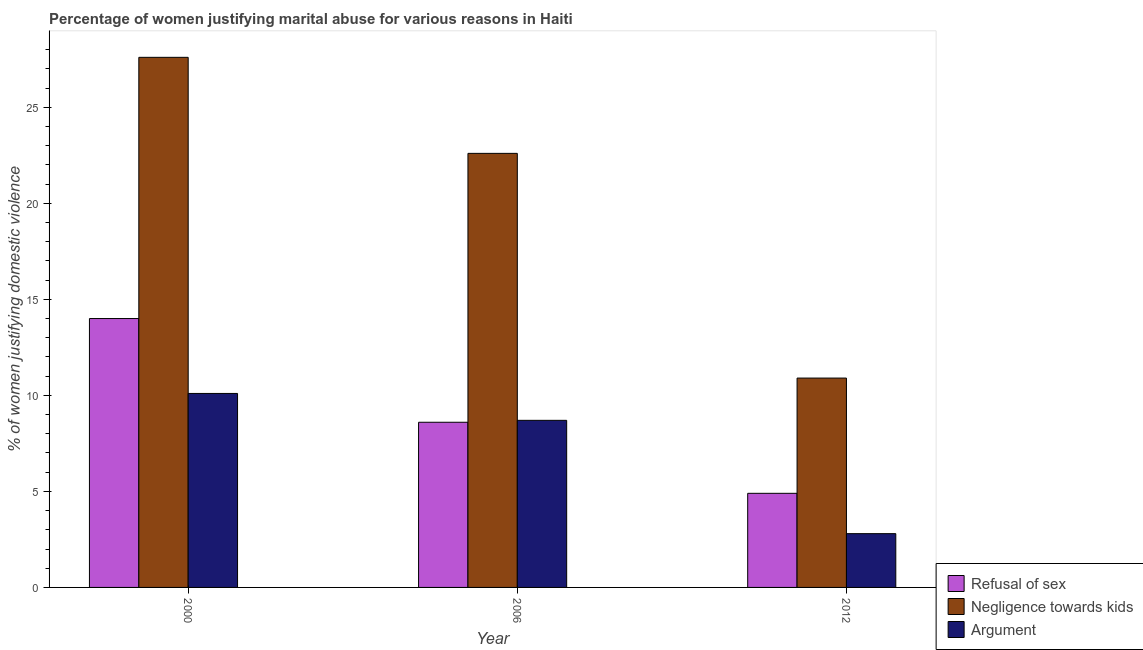How many different coloured bars are there?
Offer a very short reply. 3. How many groups of bars are there?
Offer a very short reply. 3. Are the number of bars per tick equal to the number of legend labels?
Provide a succinct answer. Yes. How many bars are there on the 1st tick from the left?
Provide a succinct answer. 3. What is the label of the 3rd group of bars from the left?
Provide a succinct answer. 2012. What is the percentage of women justifying domestic violence due to refusal of sex in 2006?
Keep it short and to the point. 8.6. Across all years, what is the minimum percentage of women justifying domestic violence due to arguments?
Provide a short and direct response. 2.8. In which year was the percentage of women justifying domestic violence due to refusal of sex maximum?
Offer a very short reply. 2000. What is the total percentage of women justifying domestic violence due to refusal of sex in the graph?
Offer a very short reply. 27.5. What is the average percentage of women justifying domestic violence due to refusal of sex per year?
Offer a terse response. 9.17. In how many years, is the percentage of women justifying domestic violence due to arguments greater than 21 %?
Your response must be concise. 0. What is the ratio of the percentage of women justifying domestic violence due to negligence towards kids in 2006 to that in 2012?
Keep it short and to the point. 2.07. Is the percentage of women justifying domestic violence due to arguments in 2000 less than that in 2012?
Ensure brevity in your answer.  No. What is the difference between the highest and the second highest percentage of women justifying domestic violence due to arguments?
Provide a succinct answer. 1.4. Is the sum of the percentage of women justifying domestic violence due to negligence towards kids in 2000 and 2006 greater than the maximum percentage of women justifying domestic violence due to refusal of sex across all years?
Your answer should be very brief. Yes. What does the 3rd bar from the left in 2012 represents?
Your response must be concise. Argument. What does the 1st bar from the right in 2000 represents?
Provide a short and direct response. Argument. Is it the case that in every year, the sum of the percentage of women justifying domestic violence due to refusal of sex and percentage of women justifying domestic violence due to negligence towards kids is greater than the percentage of women justifying domestic violence due to arguments?
Provide a succinct answer. Yes. How many bars are there?
Your answer should be very brief. 9. Are all the bars in the graph horizontal?
Your answer should be compact. No. Are the values on the major ticks of Y-axis written in scientific E-notation?
Keep it short and to the point. No. Does the graph contain any zero values?
Keep it short and to the point. No. Does the graph contain grids?
Provide a succinct answer. No. Where does the legend appear in the graph?
Your response must be concise. Bottom right. How many legend labels are there?
Offer a terse response. 3. How are the legend labels stacked?
Keep it short and to the point. Vertical. What is the title of the graph?
Give a very brief answer. Percentage of women justifying marital abuse for various reasons in Haiti. Does "Taxes on international trade" appear as one of the legend labels in the graph?
Provide a succinct answer. No. What is the label or title of the Y-axis?
Ensure brevity in your answer.  % of women justifying domestic violence. What is the % of women justifying domestic violence of Refusal of sex in 2000?
Your answer should be very brief. 14. What is the % of women justifying domestic violence of Negligence towards kids in 2000?
Provide a succinct answer. 27.6. What is the % of women justifying domestic violence in Negligence towards kids in 2006?
Keep it short and to the point. 22.6. What is the % of women justifying domestic violence of Negligence towards kids in 2012?
Provide a succinct answer. 10.9. What is the % of women justifying domestic violence in Argument in 2012?
Give a very brief answer. 2.8. Across all years, what is the maximum % of women justifying domestic violence in Refusal of sex?
Give a very brief answer. 14. Across all years, what is the maximum % of women justifying domestic violence in Negligence towards kids?
Offer a very short reply. 27.6. Across all years, what is the maximum % of women justifying domestic violence of Argument?
Ensure brevity in your answer.  10.1. Across all years, what is the minimum % of women justifying domestic violence in Refusal of sex?
Keep it short and to the point. 4.9. What is the total % of women justifying domestic violence of Negligence towards kids in the graph?
Ensure brevity in your answer.  61.1. What is the total % of women justifying domestic violence of Argument in the graph?
Offer a very short reply. 21.6. What is the difference between the % of women justifying domestic violence of Argument in 2000 and that in 2006?
Ensure brevity in your answer.  1.4. What is the difference between the % of women justifying domestic violence of Negligence towards kids in 2000 and that in 2012?
Give a very brief answer. 16.7. What is the difference between the % of women justifying domestic violence in Argument in 2000 and that in 2012?
Make the answer very short. 7.3. What is the difference between the % of women justifying domestic violence of Refusal of sex in 2006 and that in 2012?
Provide a short and direct response. 3.7. What is the difference between the % of women justifying domestic violence in Argument in 2006 and that in 2012?
Provide a succinct answer. 5.9. What is the difference between the % of women justifying domestic violence in Refusal of sex in 2000 and the % of women justifying domestic violence in Negligence towards kids in 2006?
Offer a very short reply. -8.6. What is the difference between the % of women justifying domestic violence of Negligence towards kids in 2000 and the % of women justifying domestic violence of Argument in 2006?
Make the answer very short. 18.9. What is the difference between the % of women justifying domestic violence of Refusal of sex in 2000 and the % of women justifying domestic violence of Argument in 2012?
Your answer should be very brief. 11.2. What is the difference between the % of women justifying domestic violence in Negligence towards kids in 2000 and the % of women justifying domestic violence in Argument in 2012?
Offer a terse response. 24.8. What is the difference between the % of women justifying domestic violence of Negligence towards kids in 2006 and the % of women justifying domestic violence of Argument in 2012?
Your answer should be compact. 19.8. What is the average % of women justifying domestic violence in Refusal of sex per year?
Give a very brief answer. 9.17. What is the average % of women justifying domestic violence of Negligence towards kids per year?
Your answer should be very brief. 20.37. In the year 2000, what is the difference between the % of women justifying domestic violence in Refusal of sex and % of women justifying domestic violence in Negligence towards kids?
Make the answer very short. -13.6. In the year 2000, what is the difference between the % of women justifying domestic violence in Negligence towards kids and % of women justifying domestic violence in Argument?
Make the answer very short. 17.5. In the year 2006, what is the difference between the % of women justifying domestic violence of Refusal of sex and % of women justifying domestic violence of Argument?
Offer a very short reply. -0.1. In the year 2006, what is the difference between the % of women justifying domestic violence in Negligence towards kids and % of women justifying domestic violence in Argument?
Your response must be concise. 13.9. In the year 2012, what is the difference between the % of women justifying domestic violence in Negligence towards kids and % of women justifying domestic violence in Argument?
Provide a succinct answer. 8.1. What is the ratio of the % of women justifying domestic violence of Refusal of sex in 2000 to that in 2006?
Your answer should be compact. 1.63. What is the ratio of the % of women justifying domestic violence of Negligence towards kids in 2000 to that in 2006?
Provide a short and direct response. 1.22. What is the ratio of the % of women justifying domestic violence in Argument in 2000 to that in 2006?
Ensure brevity in your answer.  1.16. What is the ratio of the % of women justifying domestic violence in Refusal of sex in 2000 to that in 2012?
Provide a short and direct response. 2.86. What is the ratio of the % of women justifying domestic violence of Negligence towards kids in 2000 to that in 2012?
Give a very brief answer. 2.53. What is the ratio of the % of women justifying domestic violence in Argument in 2000 to that in 2012?
Offer a very short reply. 3.61. What is the ratio of the % of women justifying domestic violence in Refusal of sex in 2006 to that in 2012?
Keep it short and to the point. 1.76. What is the ratio of the % of women justifying domestic violence in Negligence towards kids in 2006 to that in 2012?
Your answer should be compact. 2.07. What is the ratio of the % of women justifying domestic violence of Argument in 2006 to that in 2012?
Provide a succinct answer. 3.11. What is the difference between the highest and the second highest % of women justifying domestic violence in Refusal of sex?
Ensure brevity in your answer.  5.4. What is the difference between the highest and the second highest % of women justifying domestic violence of Argument?
Give a very brief answer. 1.4. What is the difference between the highest and the lowest % of women justifying domestic violence of Refusal of sex?
Offer a terse response. 9.1. 